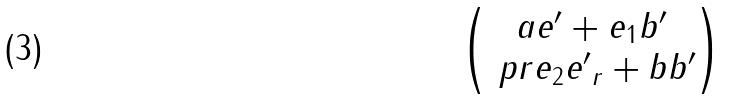<formula> <loc_0><loc_0><loc_500><loc_500>\begin{pmatrix} a e ^ { \prime } + e _ { 1 } b ^ { \prime } \\ \ p r { e _ { 2 } } { e ^ { \prime } } _ { r } + b b ^ { \prime } \end{pmatrix}</formula> 